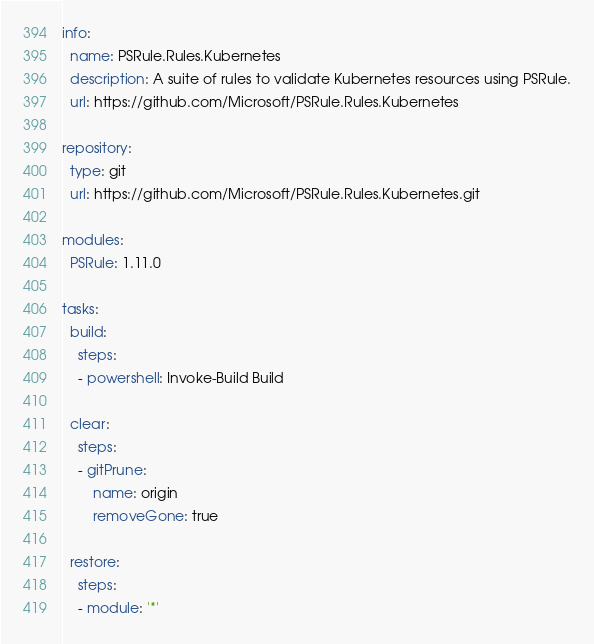Convert code to text. <code><loc_0><loc_0><loc_500><loc_500><_YAML_>
info:
  name: PSRule.Rules.Kubernetes
  description: A suite of rules to validate Kubernetes resources using PSRule.
  url: https://github.com/Microsoft/PSRule.Rules.Kubernetes

repository:
  type: git
  url: https://github.com/Microsoft/PSRule.Rules.Kubernetes.git

modules:
  PSRule: 1.11.0

tasks:
  build:
    steps:
    - powershell: Invoke-Build Build

  clear:
    steps:
    - gitPrune:
        name: origin
        removeGone: true

  restore:
    steps:
    - module: '*'
</code> 